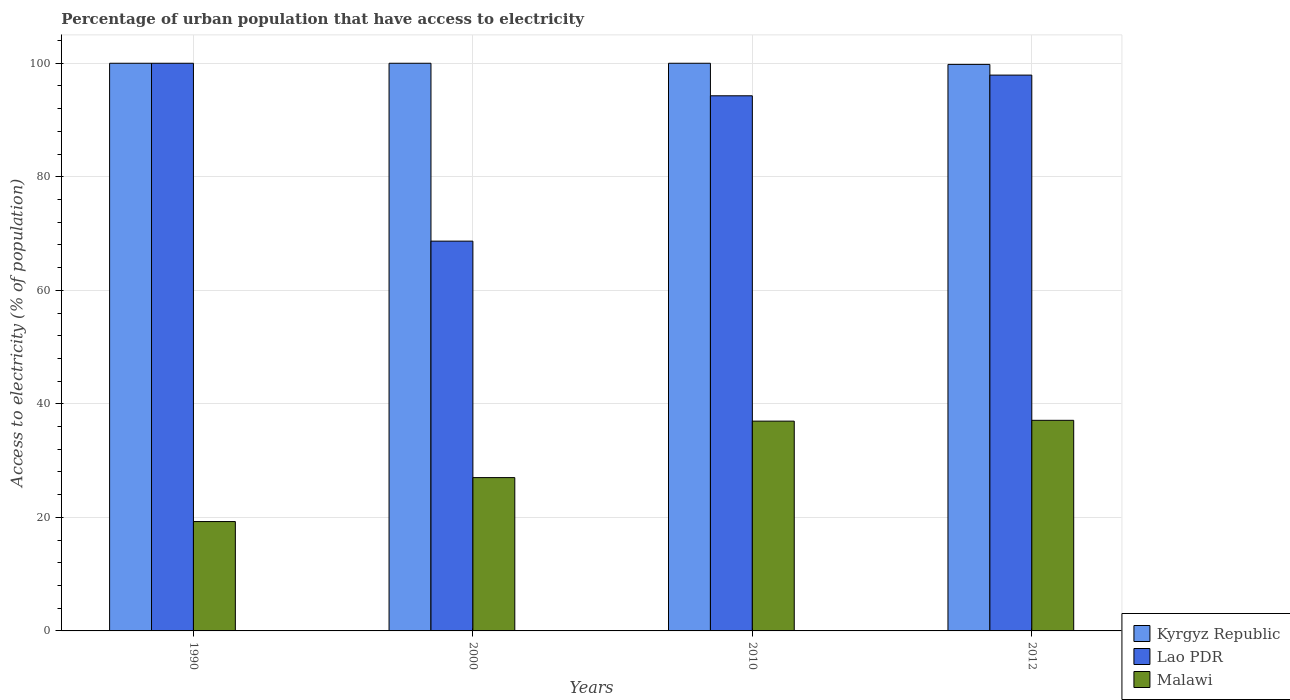How many groups of bars are there?
Your answer should be compact. 4. Are the number of bars on each tick of the X-axis equal?
Offer a very short reply. Yes. How many bars are there on the 2nd tick from the left?
Provide a short and direct response. 3. In how many cases, is the number of bars for a given year not equal to the number of legend labels?
Provide a short and direct response. 0. What is the percentage of urban population that have access to electricity in Malawi in 1990?
Give a very brief answer. 19.27. Across all years, what is the minimum percentage of urban population that have access to electricity in Lao PDR?
Offer a very short reply. 68.67. In which year was the percentage of urban population that have access to electricity in Kyrgyz Republic minimum?
Ensure brevity in your answer.  2012. What is the total percentage of urban population that have access to electricity in Malawi in the graph?
Provide a succinct answer. 120.33. What is the difference between the percentage of urban population that have access to electricity in Malawi in 2000 and that in 2010?
Offer a terse response. -9.95. What is the difference between the percentage of urban population that have access to electricity in Malawi in 2010 and the percentage of urban population that have access to electricity in Lao PDR in 2012?
Provide a short and direct response. -60.96. What is the average percentage of urban population that have access to electricity in Kyrgyz Republic per year?
Ensure brevity in your answer.  99.95. In the year 2012, what is the difference between the percentage of urban population that have access to electricity in Lao PDR and percentage of urban population that have access to electricity in Malawi?
Provide a succinct answer. 60.81. What is the ratio of the percentage of urban population that have access to electricity in Lao PDR in 1990 to that in 2000?
Offer a terse response. 1.46. What is the difference between the highest and the second highest percentage of urban population that have access to electricity in Lao PDR?
Your response must be concise. 2.09. What is the difference between the highest and the lowest percentage of urban population that have access to electricity in Malawi?
Make the answer very short. 17.83. In how many years, is the percentage of urban population that have access to electricity in Malawi greater than the average percentage of urban population that have access to electricity in Malawi taken over all years?
Provide a succinct answer. 2. What does the 1st bar from the left in 2000 represents?
Keep it short and to the point. Kyrgyz Republic. What does the 1st bar from the right in 1990 represents?
Your answer should be very brief. Malawi. Is it the case that in every year, the sum of the percentage of urban population that have access to electricity in Lao PDR and percentage of urban population that have access to electricity in Malawi is greater than the percentage of urban population that have access to electricity in Kyrgyz Republic?
Make the answer very short. No. How many bars are there?
Your answer should be very brief. 12. What is the difference between two consecutive major ticks on the Y-axis?
Your response must be concise. 20. How many legend labels are there?
Keep it short and to the point. 3. What is the title of the graph?
Provide a short and direct response. Percentage of urban population that have access to electricity. Does "Tonga" appear as one of the legend labels in the graph?
Make the answer very short. No. What is the label or title of the Y-axis?
Keep it short and to the point. Access to electricity (% of population). What is the Access to electricity (% of population) in Kyrgyz Republic in 1990?
Give a very brief answer. 100. What is the Access to electricity (% of population) in Malawi in 1990?
Provide a short and direct response. 19.27. What is the Access to electricity (% of population) in Lao PDR in 2000?
Offer a very short reply. 68.67. What is the Access to electricity (% of population) in Malawi in 2000?
Keep it short and to the point. 27.01. What is the Access to electricity (% of population) of Kyrgyz Republic in 2010?
Provide a succinct answer. 100. What is the Access to electricity (% of population) of Lao PDR in 2010?
Offer a terse response. 94.27. What is the Access to electricity (% of population) in Malawi in 2010?
Keep it short and to the point. 36.96. What is the Access to electricity (% of population) of Kyrgyz Republic in 2012?
Make the answer very short. 99.8. What is the Access to electricity (% of population) of Lao PDR in 2012?
Give a very brief answer. 97.91. What is the Access to electricity (% of population) in Malawi in 2012?
Give a very brief answer. 37.1. Across all years, what is the maximum Access to electricity (% of population) of Kyrgyz Republic?
Give a very brief answer. 100. Across all years, what is the maximum Access to electricity (% of population) in Lao PDR?
Provide a short and direct response. 100. Across all years, what is the maximum Access to electricity (% of population) of Malawi?
Offer a terse response. 37.1. Across all years, what is the minimum Access to electricity (% of population) in Kyrgyz Republic?
Ensure brevity in your answer.  99.8. Across all years, what is the minimum Access to electricity (% of population) in Lao PDR?
Offer a very short reply. 68.67. Across all years, what is the minimum Access to electricity (% of population) in Malawi?
Offer a very short reply. 19.27. What is the total Access to electricity (% of population) in Kyrgyz Republic in the graph?
Provide a succinct answer. 399.8. What is the total Access to electricity (% of population) in Lao PDR in the graph?
Provide a succinct answer. 360.85. What is the total Access to electricity (% of population) in Malawi in the graph?
Provide a short and direct response. 120.33. What is the difference between the Access to electricity (% of population) in Kyrgyz Republic in 1990 and that in 2000?
Make the answer very short. 0. What is the difference between the Access to electricity (% of population) of Lao PDR in 1990 and that in 2000?
Keep it short and to the point. 31.33. What is the difference between the Access to electricity (% of population) in Malawi in 1990 and that in 2000?
Ensure brevity in your answer.  -7.74. What is the difference between the Access to electricity (% of population) in Kyrgyz Republic in 1990 and that in 2010?
Your response must be concise. 0. What is the difference between the Access to electricity (% of population) in Lao PDR in 1990 and that in 2010?
Ensure brevity in your answer.  5.73. What is the difference between the Access to electricity (% of population) in Malawi in 1990 and that in 2010?
Your answer should be very brief. -17.69. What is the difference between the Access to electricity (% of population) in Lao PDR in 1990 and that in 2012?
Provide a succinct answer. 2.09. What is the difference between the Access to electricity (% of population) in Malawi in 1990 and that in 2012?
Your answer should be compact. -17.83. What is the difference between the Access to electricity (% of population) of Lao PDR in 2000 and that in 2010?
Your response must be concise. -25.6. What is the difference between the Access to electricity (% of population) in Malawi in 2000 and that in 2010?
Ensure brevity in your answer.  -9.95. What is the difference between the Access to electricity (% of population) in Lao PDR in 2000 and that in 2012?
Offer a very short reply. -29.25. What is the difference between the Access to electricity (% of population) in Malawi in 2000 and that in 2012?
Offer a very short reply. -10.09. What is the difference between the Access to electricity (% of population) of Kyrgyz Republic in 2010 and that in 2012?
Give a very brief answer. 0.2. What is the difference between the Access to electricity (% of population) in Lao PDR in 2010 and that in 2012?
Give a very brief answer. -3.64. What is the difference between the Access to electricity (% of population) of Malawi in 2010 and that in 2012?
Keep it short and to the point. -0.14. What is the difference between the Access to electricity (% of population) of Kyrgyz Republic in 1990 and the Access to electricity (% of population) of Lao PDR in 2000?
Provide a short and direct response. 31.33. What is the difference between the Access to electricity (% of population) in Kyrgyz Republic in 1990 and the Access to electricity (% of population) in Malawi in 2000?
Offer a very short reply. 72.99. What is the difference between the Access to electricity (% of population) in Lao PDR in 1990 and the Access to electricity (% of population) in Malawi in 2000?
Offer a very short reply. 72.99. What is the difference between the Access to electricity (% of population) of Kyrgyz Republic in 1990 and the Access to electricity (% of population) of Lao PDR in 2010?
Your answer should be compact. 5.73. What is the difference between the Access to electricity (% of population) in Kyrgyz Republic in 1990 and the Access to electricity (% of population) in Malawi in 2010?
Provide a succinct answer. 63.04. What is the difference between the Access to electricity (% of population) in Lao PDR in 1990 and the Access to electricity (% of population) in Malawi in 2010?
Keep it short and to the point. 63.04. What is the difference between the Access to electricity (% of population) in Kyrgyz Republic in 1990 and the Access to electricity (% of population) in Lao PDR in 2012?
Give a very brief answer. 2.09. What is the difference between the Access to electricity (% of population) of Kyrgyz Republic in 1990 and the Access to electricity (% of population) of Malawi in 2012?
Give a very brief answer. 62.9. What is the difference between the Access to electricity (% of population) in Lao PDR in 1990 and the Access to electricity (% of population) in Malawi in 2012?
Make the answer very short. 62.9. What is the difference between the Access to electricity (% of population) of Kyrgyz Republic in 2000 and the Access to electricity (% of population) of Lao PDR in 2010?
Offer a very short reply. 5.73. What is the difference between the Access to electricity (% of population) in Kyrgyz Republic in 2000 and the Access to electricity (% of population) in Malawi in 2010?
Make the answer very short. 63.04. What is the difference between the Access to electricity (% of population) in Lao PDR in 2000 and the Access to electricity (% of population) in Malawi in 2010?
Your answer should be compact. 31.71. What is the difference between the Access to electricity (% of population) in Kyrgyz Republic in 2000 and the Access to electricity (% of population) in Lao PDR in 2012?
Your answer should be compact. 2.09. What is the difference between the Access to electricity (% of population) in Kyrgyz Republic in 2000 and the Access to electricity (% of population) in Malawi in 2012?
Give a very brief answer. 62.9. What is the difference between the Access to electricity (% of population) in Lao PDR in 2000 and the Access to electricity (% of population) in Malawi in 2012?
Keep it short and to the point. 31.57. What is the difference between the Access to electricity (% of population) of Kyrgyz Republic in 2010 and the Access to electricity (% of population) of Lao PDR in 2012?
Keep it short and to the point. 2.09. What is the difference between the Access to electricity (% of population) in Kyrgyz Republic in 2010 and the Access to electricity (% of population) in Malawi in 2012?
Offer a very short reply. 62.9. What is the difference between the Access to electricity (% of population) in Lao PDR in 2010 and the Access to electricity (% of population) in Malawi in 2012?
Make the answer very short. 57.17. What is the average Access to electricity (% of population) in Kyrgyz Republic per year?
Ensure brevity in your answer.  99.95. What is the average Access to electricity (% of population) of Lao PDR per year?
Your answer should be compact. 90.21. What is the average Access to electricity (% of population) in Malawi per year?
Offer a very short reply. 30.08. In the year 1990, what is the difference between the Access to electricity (% of population) of Kyrgyz Republic and Access to electricity (% of population) of Lao PDR?
Provide a short and direct response. 0. In the year 1990, what is the difference between the Access to electricity (% of population) in Kyrgyz Republic and Access to electricity (% of population) in Malawi?
Offer a very short reply. 80.73. In the year 1990, what is the difference between the Access to electricity (% of population) in Lao PDR and Access to electricity (% of population) in Malawi?
Offer a terse response. 80.73. In the year 2000, what is the difference between the Access to electricity (% of population) of Kyrgyz Republic and Access to electricity (% of population) of Lao PDR?
Keep it short and to the point. 31.33. In the year 2000, what is the difference between the Access to electricity (% of population) of Kyrgyz Republic and Access to electricity (% of population) of Malawi?
Offer a terse response. 72.99. In the year 2000, what is the difference between the Access to electricity (% of population) of Lao PDR and Access to electricity (% of population) of Malawi?
Your response must be concise. 41.66. In the year 2010, what is the difference between the Access to electricity (% of population) of Kyrgyz Republic and Access to electricity (% of population) of Lao PDR?
Offer a very short reply. 5.73. In the year 2010, what is the difference between the Access to electricity (% of population) in Kyrgyz Republic and Access to electricity (% of population) in Malawi?
Offer a very short reply. 63.04. In the year 2010, what is the difference between the Access to electricity (% of population) of Lao PDR and Access to electricity (% of population) of Malawi?
Your response must be concise. 57.31. In the year 2012, what is the difference between the Access to electricity (% of population) in Kyrgyz Republic and Access to electricity (% of population) in Lao PDR?
Your answer should be compact. 1.89. In the year 2012, what is the difference between the Access to electricity (% of population) in Kyrgyz Republic and Access to electricity (% of population) in Malawi?
Your answer should be compact. 62.7. In the year 2012, what is the difference between the Access to electricity (% of population) of Lao PDR and Access to electricity (% of population) of Malawi?
Provide a succinct answer. 60.81. What is the ratio of the Access to electricity (% of population) in Kyrgyz Republic in 1990 to that in 2000?
Your answer should be compact. 1. What is the ratio of the Access to electricity (% of population) of Lao PDR in 1990 to that in 2000?
Keep it short and to the point. 1.46. What is the ratio of the Access to electricity (% of population) of Malawi in 1990 to that in 2000?
Ensure brevity in your answer.  0.71. What is the ratio of the Access to electricity (% of population) of Lao PDR in 1990 to that in 2010?
Provide a short and direct response. 1.06. What is the ratio of the Access to electricity (% of population) in Malawi in 1990 to that in 2010?
Offer a terse response. 0.52. What is the ratio of the Access to electricity (% of population) in Lao PDR in 1990 to that in 2012?
Make the answer very short. 1.02. What is the ratio of the Access to electricity (% of population) in Malawi in 1990 to that in 2012?
Give a very brief answer. 0.52. What is the ratio of the Access to electricity (% of population) of Lao PDR in 2000 to that in 2010?
Offer a terse response. 0.73. What is the ratio of the Access to electricity (% of population) of Malawi in 2000 to that in 2010?
Ensure brevity in your answer.  0.73. What is the ratio of the Access to electricity (% of population) of Lao PDR in 2000 to that in 2012?
Your answer should be very brief. 0.7. What is the ratio of the Access to electricity (% of population) of Malawi in 2000 to that in 2012?
Your answer should be compact. 0.73. What is the ratio of the Access to electricity (% of population) of Lao PDR in 2010 to that in 2012?
Your answer should be compact. 0.96. What is the ratio of the Access to electricity (% of population) in Malawi in 2010 to that in 2012?
Provide a succinct answer. 1. What is the difference between the highest and the second highest Access to electricity (% of population) of Kyrgyz Republic?
Give a very brief answer. 0. What is the difference between the highest and the second highest Access to electricity (% of population) of Lao PDR?
Your answer should be compact. 2.09. What is the difference between the highest and the second highest Access to electricity (% of population) in Malawi?
Your response must be concise. 0.14. What is the difference between the highest and the lowest Access to electricity (% of population) of Lao PDR?
Your response must be concise. 31.33. What is the difference between the highest and the lowest Access to electricity (% of population) in Malawi?
Keep it short and to the point. 17.83. 